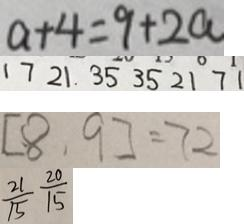Convert formula to latex. <formula><loc_0><loc_0><loc_500><loc_500>a + 4 = 9 + 2 a 
 1 7 2 1 . 3 5 3 5 2 1 7 1 
 [ 8 . 9 ] = 7 2 
 \frac { 2 1 } { 1 5 } \frac { 2 0 } { 1 5 }</formula> 